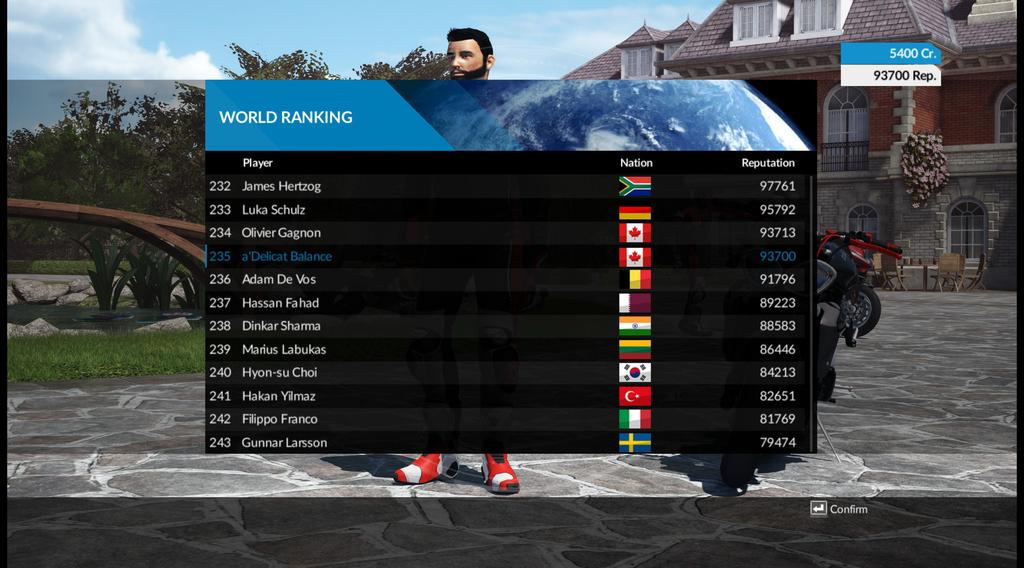What is the number beside the first ranked player?
Make the answer very short. 232. 